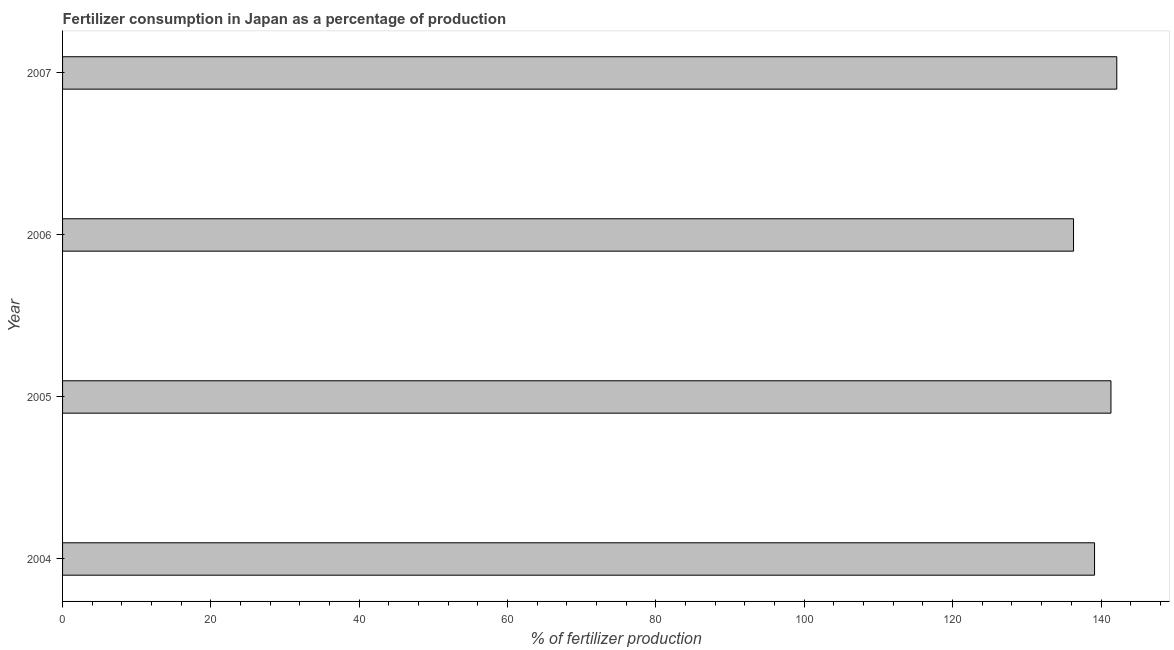What is the title of the graph?
Your answer should be compact. Fertilizer consumption in Japan as a percentage of production. What is the label or title of the X-axis?
Ensure brevity in your answer.  % of fertilizer production. What is the amount of fertilizer consumption in 2006?
Offer a very short reply. 136.3. Across all years, what is the maximum amount of fertilizer consumption?
Offer a very short reply. 142.13. Across all years, what is the minimum amount of fertilizer consumption?
Give a very brief answer. 136.3. What is the sum of the amount of fertilizer consumption?
Your answer should be compact. 558.9. What is the difference between the amount of fertilizer consumption in 2006 and 2007?
Offer a terse response. -5.83. What is the average amount of fertilizer consumption per year?
Offer a very short reply. 139.72. What is the median amount of fertilizer consumption?
Provide a succinct answer. 140.24. Is the amount of fertilizer consumption in 2004 less than that in 2007?
Your response must be concise. Yes. Is the difference between the amount of fertilizer consumption in 2004 and 2007 greater than the difference between any two years?
Offer a terse response. No. What is the difference between the highest and the second highest amount of fertilizer consumption?
Keep it short and to the point. 0.79. What is the difference between the highest and the lowest amount of fertilizer consumption?
Keep it short and to the point. 5.83. How many bars are there?
Offer a very short reply. 4. What is the difference between two consecutive major ticks on the X-axis?
Offer a terse response. 20. Are the values on the major ticks of X-axis written in scientific E-notation?
Make the answer very short. No. What is the % of fertilizer production in 2004?
Your answer should be compact. 139.13. What is the % of fertilizer production in 2005?
Your answer should be very brief. 141.34. What is the % of fertilizer production of 2006?
Offer a terse response. 136.3. What is the % of fertilizer production of 2007?
Make the answer very short. 142.13. What is the difference between the % of fertilizer production in 2004 and 2005?
Provide a short and direct response. -2.21. What is the difference between the % of fertilizer production in 2004 and 2006?
Provide a short and direct response. 2.83. What is the difference between the % of fertilizer production in 2004 and 2007?
Provide a succinct answer. -3. What is the difference between the % of fertilizer production in 2005 and 2006?
Provide a succinct answer. 5.05. What is the difference between the % of fertilizer production in 2005 and 2007?
Offer a very short reply. -0.79. What is the difference between the % of fertilizer production in 2006 and 2007?
Keep it short and to the point. -5.83. What is the ratio of the % of fertilizer production in 2005 to that in 2007?
Provide a short and direct response. 0.99. 